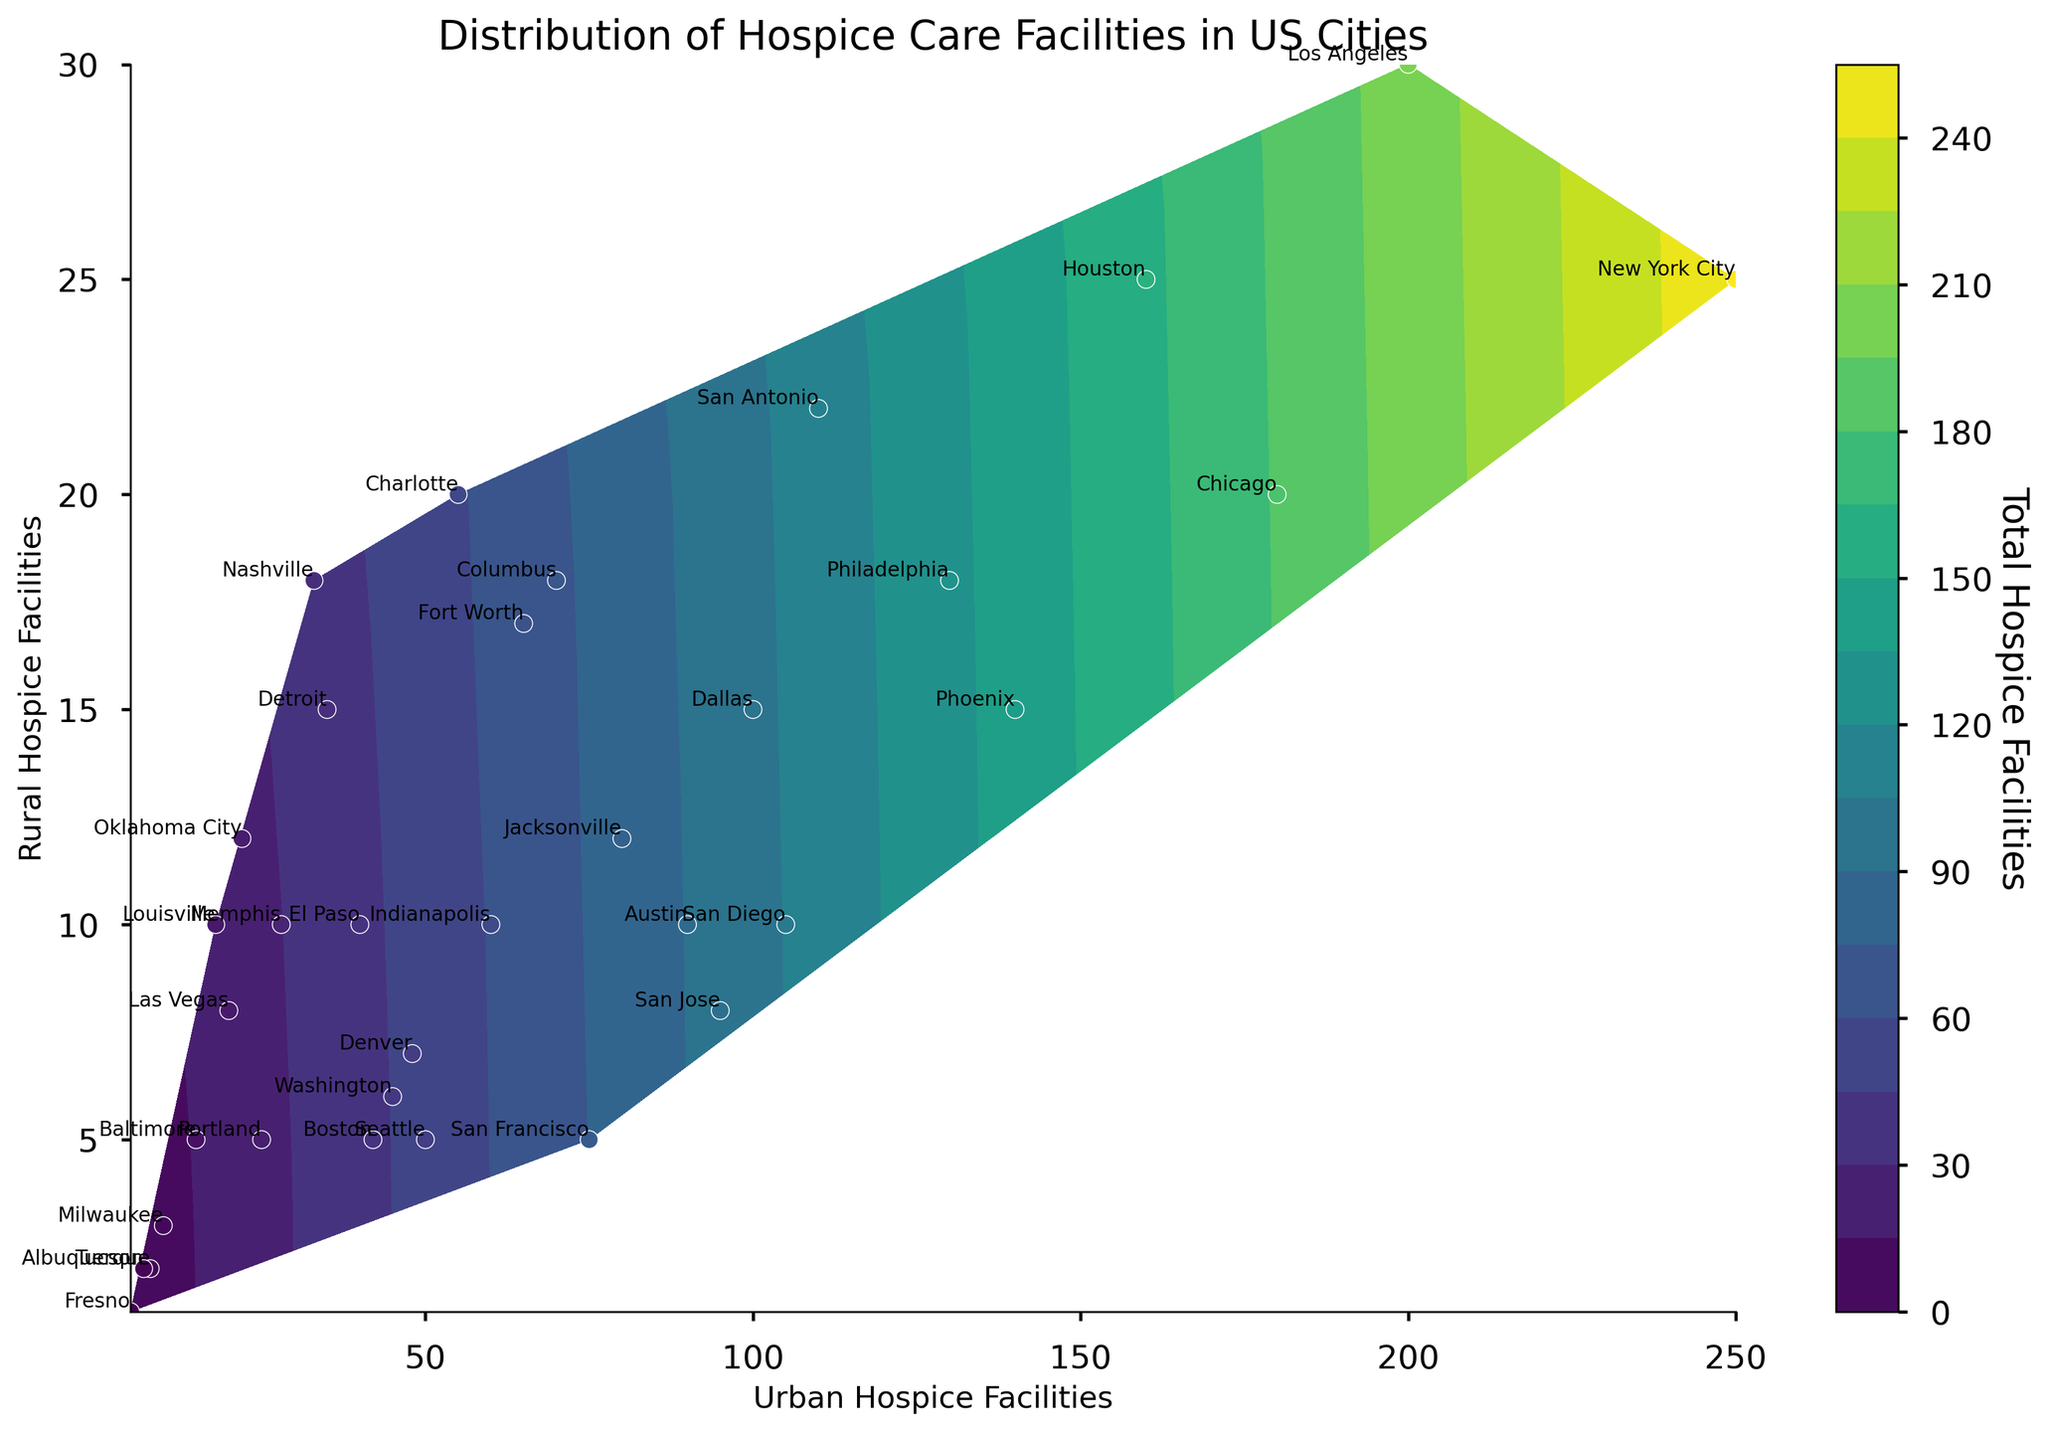What's the title of the figure? The title of the figure is the text written at the top, which explains what the figure is about.
Answer: Distribution of Hospice Care Facilities in US Cities What are the labels on the x and y-axis? The x-axis and y-axis labels describe what each axis represents in the plot. The x-axis label is shown horizontally, and the y-axis label is shown vertically.
Answer: Urban Hospice Facilities (x-axis), Rural Hospice Facilities (y-axis) Which city has the highest number of urban hospice facilities? By looking at the data points along the x-axis and identifying which one is furthest to the right, you can determine the city with the highest number of urban hospice facilities.
Answer: New York City How many rural hospice facilities are there in Philadelphia? Look for the point with the label "Philadelphia" and refer to its position on the y-axis to find the number of rural hospice facilities.
Answer: 18 Which city has more urban hospice facilities, Dallas or San Diego? Compare the x-axis positions of the points labeled "Dallas" and "San Diego" to see which one is further to the right.
Answer: Dallas Which city has approximately equal numbers of urban and rural hospice facilities? Look for cities where the points are close to a diagonal line from the bottom left to the top right, indicating similar numbers of urban and rural facilities.
Answer: Oklahoma City What's the color associated with the highest total hospice facilities? The color bar next to the plot shows the mapping of colors to the total number of hospice facilities. The color at the top of the color bar corresponds to the highest totals.
Answer: Dark Purple How many cities have more than 100 urban hospice facilities? Identify data points with an x-axis value greater than 100 and count the number of these points.
Answer: 7 Cities Which cities have the smallest number of total hospice facilities? Find the point or points that are positioned closest to the bottom left corner of the plot where both x and y values are small.
Answer: Fresno, Albuquerque, Tucson 